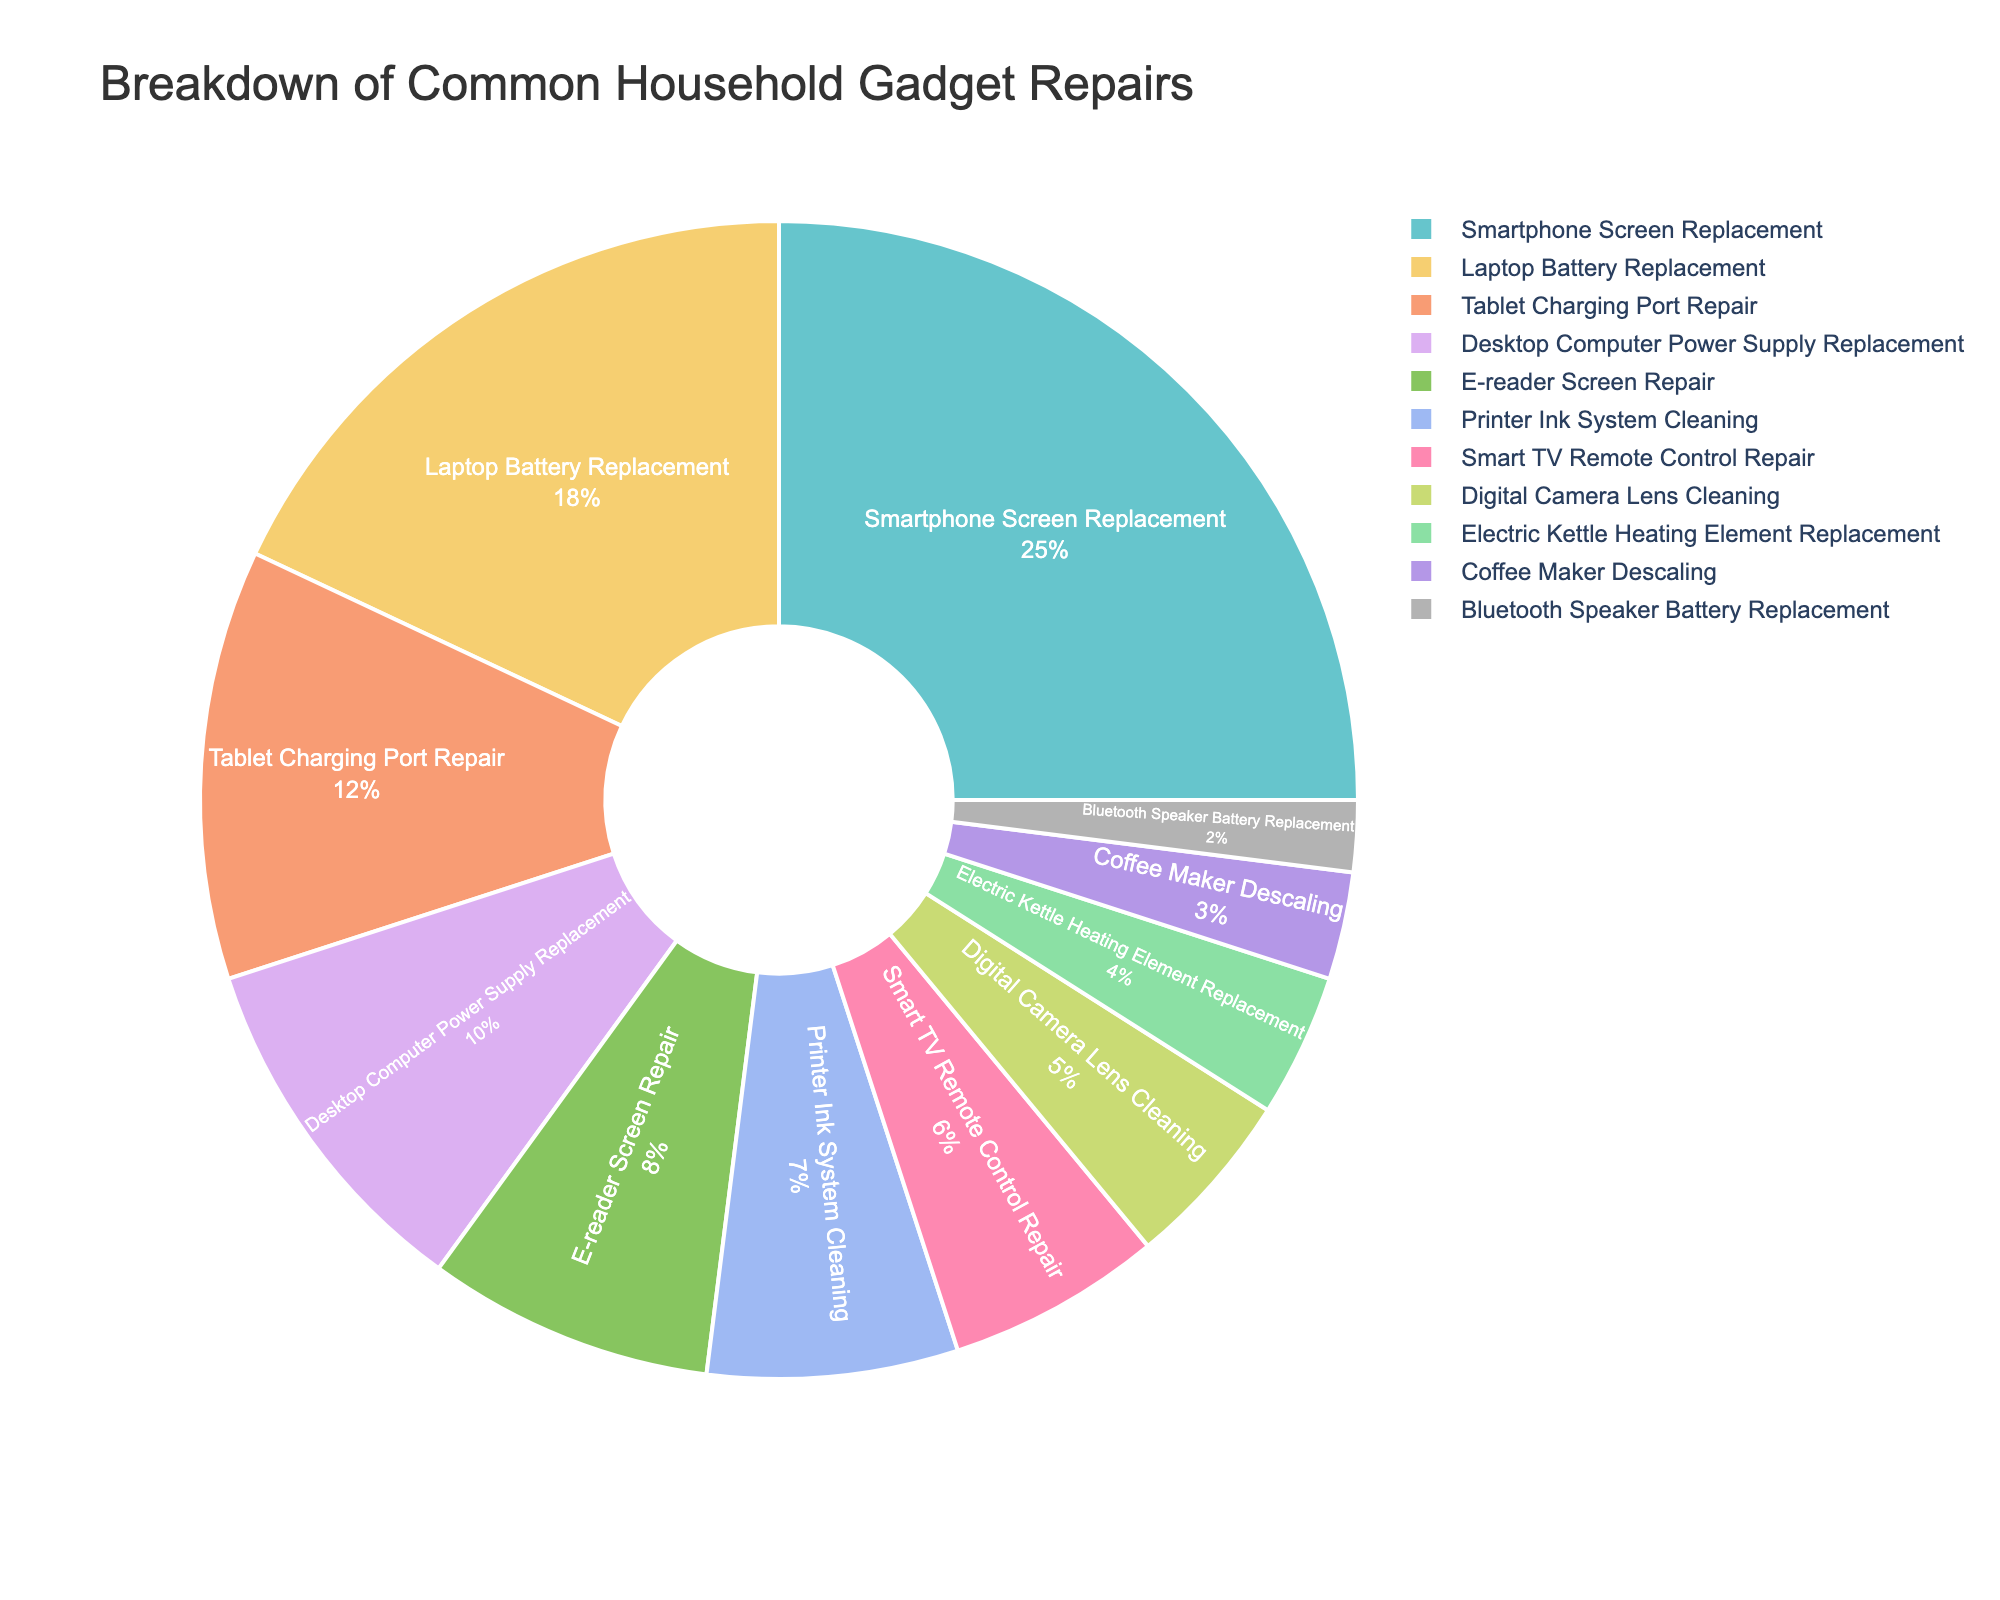What's the most common type of household gadget repair? Look at the pie chart and find the segment with the largest percentage. The smartphone screen replacement segment has the largest value at 25%.
Answer: Smartphone Screen Replacement What's the combined percentage of laptop battery replacements and desktop computer power supply replacements? Add the percentages of laptop battery replacements (18%) and desktop computer power supply replacements (10%). 18% + 10% = 28%.
Answer: 28% Which type of repair is less common: e-reader screen repair or digital camera lens cleaning? Compare the percentages of e-reader screen repair (8%) and digital camera lens cleaning (5%). 8% is greater than 5%, so digital camera lens cleaning is less common.
Answer: Digital Camera Lens Cleaning How much more common is smartphone screen replacement compared to coffee maker descaling? Subtract the percentage of coffee maker descaling (3%) from the percentage of smartphone screen replacement (25%). 25% - 3% = 22%.
Answer: 22% Are there any repair types with less than 5% representation? Check the pie chart for segments with less than 5%. Only Bluetooth speaker battery replacement is under 5% at 2%.
Answer: Yes What's the percentage difference between tablet charging port repair and printer ink system cleaning? Subtract the percentage of printer ink system cleaning (7%) from the percentage of tablet charging port repair (12%). 12% - 7% = 5%.
Answer: 5% Which has a larger percentage: smart TV remote control repair or electric kettle heating element replacement? Compare the percentages of smart TV remote control repair (6%) and electric kettle heating element replacement (4%). 6% is greater than 4%.
Answer: Smart TV Remote Control Repair How many repair types make up more than 10% of the total? Identify the segments with percentages greater than 10%. There are three segments: smartphone screen replacement (25%), laptop battery replacement (18%), and tablet charging port repair (12%).
Answer: 3 What is the total percentage of the least common five repair types? Add the percentages of the five least common repair types: Coffee maker descaling (3%), Bluetooth speaker battery replacement (2%), Electric kettle heating element replacement (4%), Digital camera lens cleaning (5%), and Smart TV remote control repair (6%). 3% + 2% + 4% + 5% + 6% = 20%.
Answer: 20% Does the combined percentage of e-reader screen repair and printer ink system cleaning equal the percentage of laptop battery replacement? Add the percentages of e-reader screen repair (8%) and printer ink system cleaning (7%) and compare it to the percentage of laptop battery replacement (18%). 8% + 7% = 15%, which is less than 18%.
Answer: No 